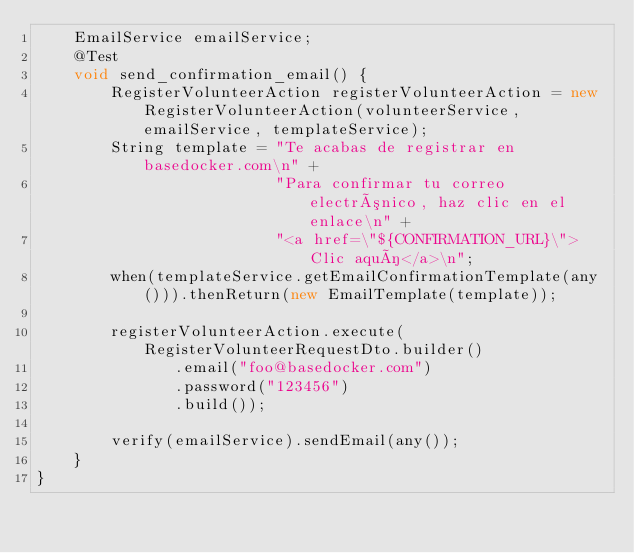Convert code to text. <code><loc_0><loc_0><loc_500><loc_500><_Java_>    EmailService emailService;
    @Test
    void send_confirmation_email() {
        RegisterVolunteerAction registerVolunteerAction = new RegisterVolunteerAction(volunteerService,emailService, templateService);
        String template = "Te acabas de registrar en basedocker.com\n" +
                          "Para confirmar tu correo electrónico, haz clic en el enlace\n" +
                          "<a href=\"${CONFIRMATION_URL}\">Clic aquí</a>\n";
        when(templateService.getEmailConfirmationTemplate(any())).thenReturn(new EmailTemplate(template));

        registerVolunteerAction.execute(RegisterVolunteerRequestDto.builder()
               .email("foo@basedocker.com")
               .password("123456")
               .build());

        verify(emailService).sendEmail(any());
    }
}
</code> 